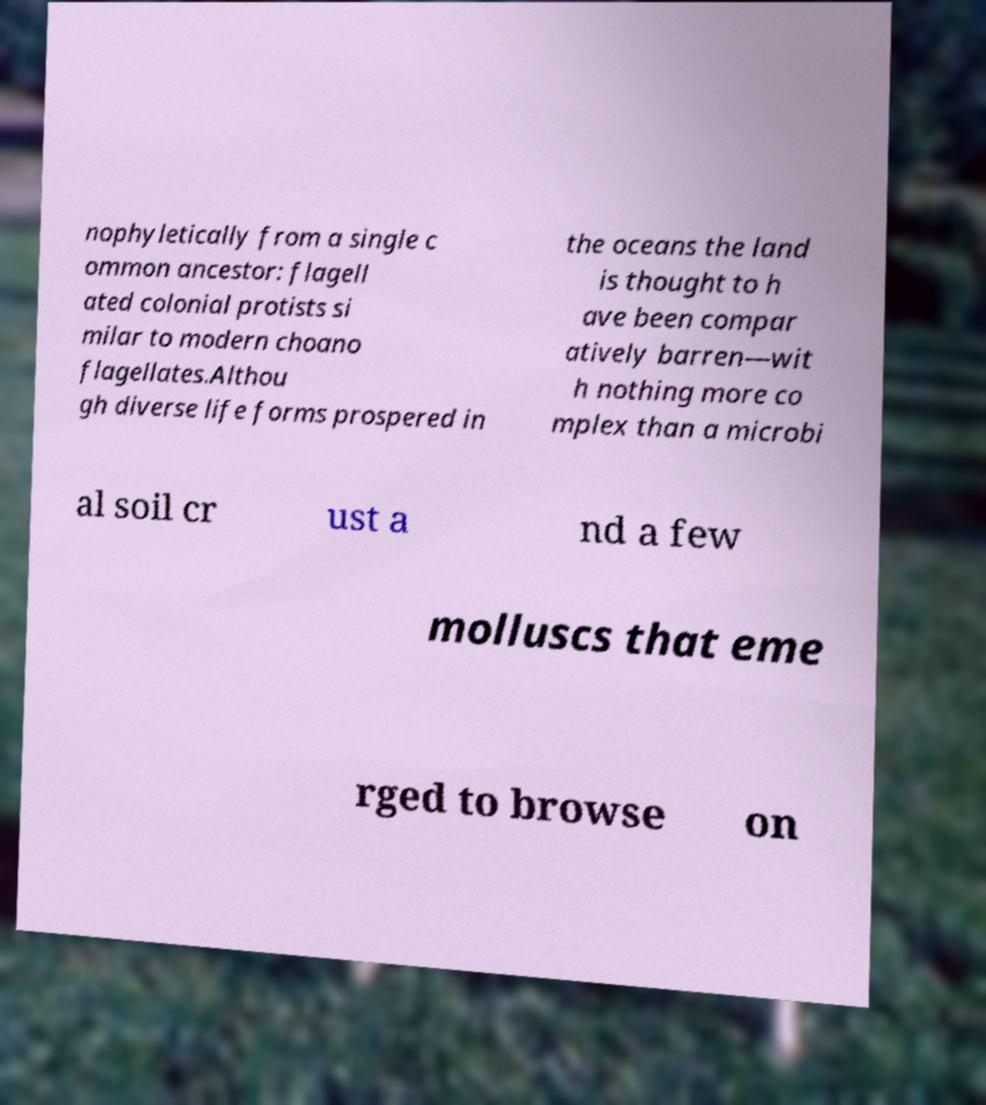I need the written content from this picture converted into text. Can you do that? nophyletically from a single c ommon ancestor: flagell ated colonial protists si milar to modern choano flagellates.Althou gh diverse life forms prospered in the oceans the land is thought to h ave been compar atively barren—wit h nothing more co mplex than a microbi al soil cr ust a nd a few molluscs that eme rged to browse on 